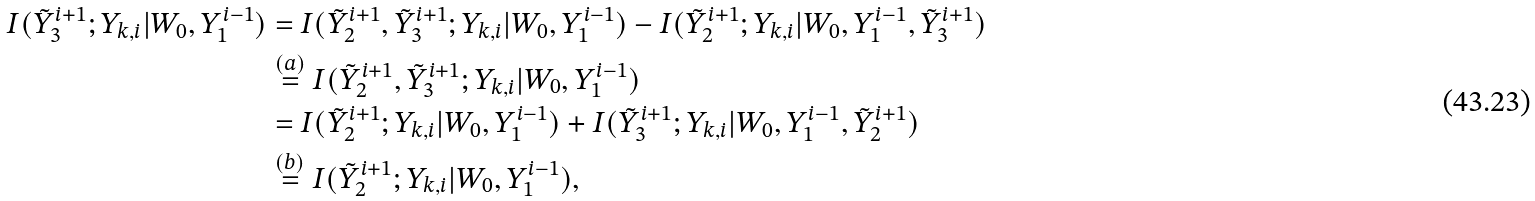<formula> <loc_0><loc_0><loc_500><loc_500>I ( \tilde { Y } _ { 3 } ^ { i + 1 } ; Y _ { k , i } | W _ { 0 } , Y _ { 1 } ^ { i - 1 } ) & = I ( \tilde { Y } _ { 2 } ^ { i + 1 } , \tilde { Y } _ { 3 } ^ { i + 1 } ; Y _ { k , i } | W _ { 0 } , Y _ { 1 } ^ { i - 1 } ) - I ( \tilde { Y } _ { 2 } ^ { i + 1 } ; Y _ { k , i } | W _ { 0 } , Y _ { 1 } ^ { i - 1 } , \tilde { Y } _ { 3 } ^ { i + 1 } ) \\ & \stackrel { ( a ) } { = } I ( \tilde { Y } _ { 2 } ^ { i + 1 } , \tilde { Y } _ { 3 } ^ { i + 1 } ; Y _ { k , i } | W _ { 0 } , Y _ { 1 } ^ { i - 1 } ) \\ & = I ( \tilde { Y } _ { 2 } ^ { i + 1 } ; Y _ { k , i } | W _ { 0 } , Y _ { 1 } ^ { i - 1 } ) + I ( \tilde { Y } _ { 3 } ^ { i + 1 } ; Y _ { k , i } | W _ { 0 } , Y _ { 1 } ^ { i - 1 } , \tilde { Y } _ { 2 } ^ { i + 1 } ) \\ & \stackrel { ( b ) } { = } I ( \tilde { Y } _ { 2 } ^ { i + 1 } ; Y _ { k , i } | W _ { 0 } , Y _ { 1 } ^ { i - 1 } ) ,</formula> 